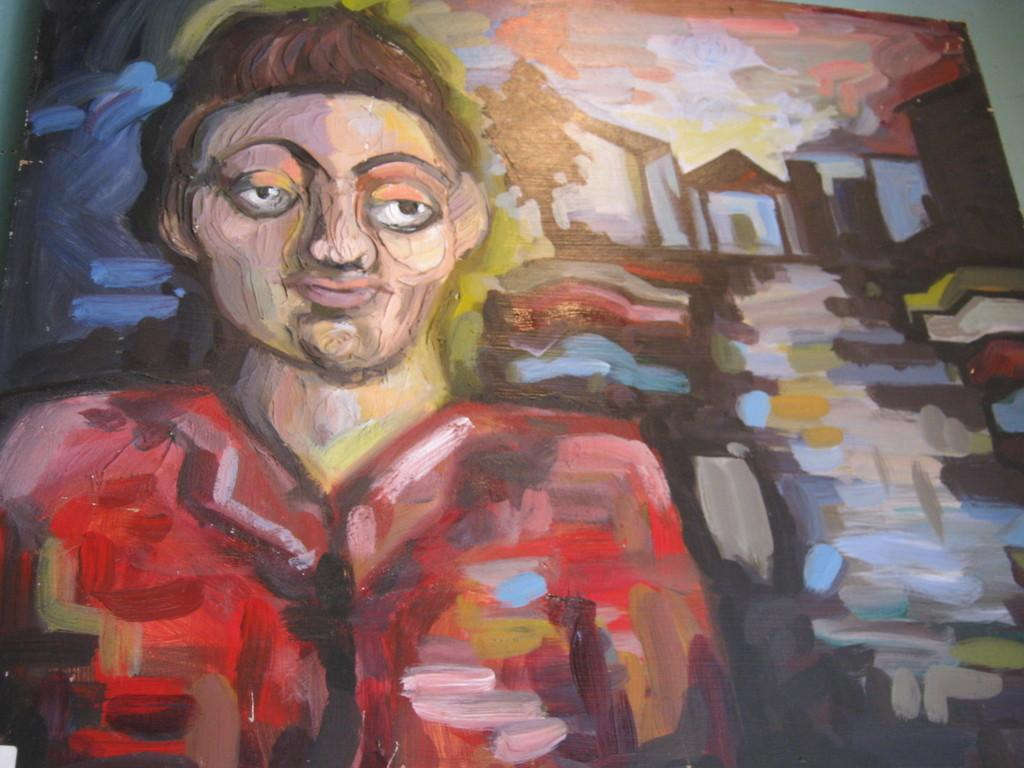What is the main subject of the painting in the image? There is a person depicted in the painting. What other elements are present in the painting? There are houses and a tree depicted in the painting. What is the medium of the artwork in the image? The painting is on a board. What type of chance does the fireman have to put out the fire in the image? There is no fire or fireman present in the image; it features a painting with a person, houses, and a tree. 